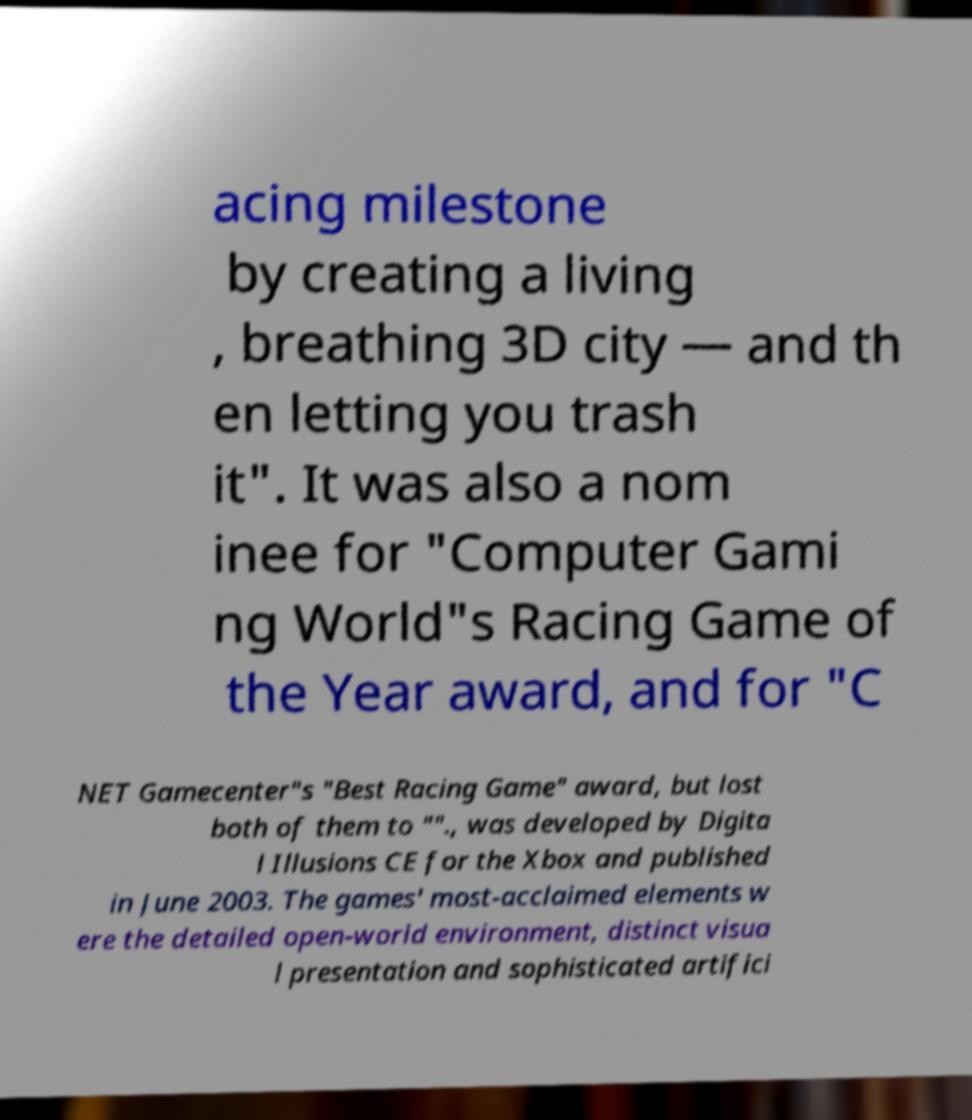What messages or text are displayed in this image? I need them in a readable, typed format. acing milestone by creating a living , breathing 3D city — and th en letting you trash it". It was also a nom inee for "Computer Gami ng World"s Racing Game of the Year award, and for "C NET Gamecenter"s "Best Racing Game" award, but lost both of them to ""., was developed by Digita l Illusions CE for the Xbox and published in June 2003. The games' most-acclaimed elements w ere the detailed open-world environment, distinct visua l presentation and sophisticated artifici 